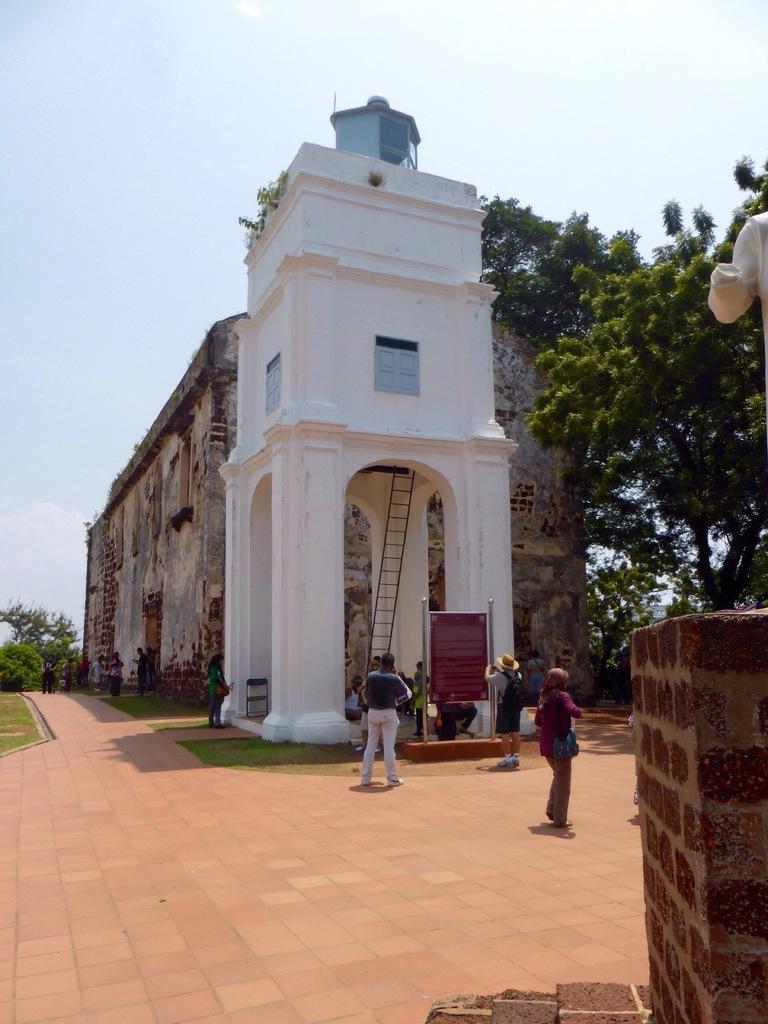Could you give a brief overview of what you see in this image? In the foreground of the picture there is a statue. In the center of the picture there is a building and there are people, board, ladder, chair and grass. In the background there are trees, people, grass and an old construction. At the top it is sky, sky is sunny. 